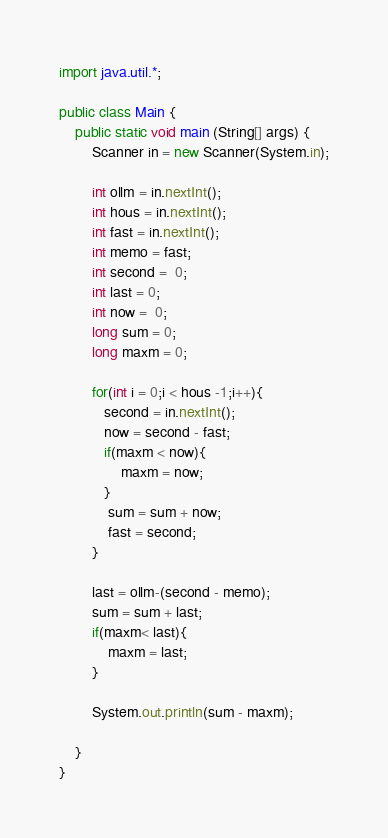Convert code to text. <code><loc_0><loc_0><loc_500><loc_500><_Java_>import java.util.*;
 
public class Main {
	public static void main (String[] args) {
		Scanner in = new Scanner(System.in);
		
		int ollm = in.nextInt();
		int hous = in.nextInt();
		int fast = in.nextInt();
		int memo = fast;
		int second =  0;
		int last = 0;
		int now =  0;
		long sum = 0;
		long maxm = 0;
		
		for(int i = 0;i < hous -1;i++){
		   second = in.nextInt();
		   now = second - fast;
		   if(maxm < now){
		       maxm = now;
		   }
		    sum = sum + now;
		    fast = second;
		}
		
		last = ollm-(second - memo);
		sum = sum + last;
		if(maxm< last){
		    maxm = last;
		}
		
		System.out.println(sum - maxm);
      
	}
}</code> 